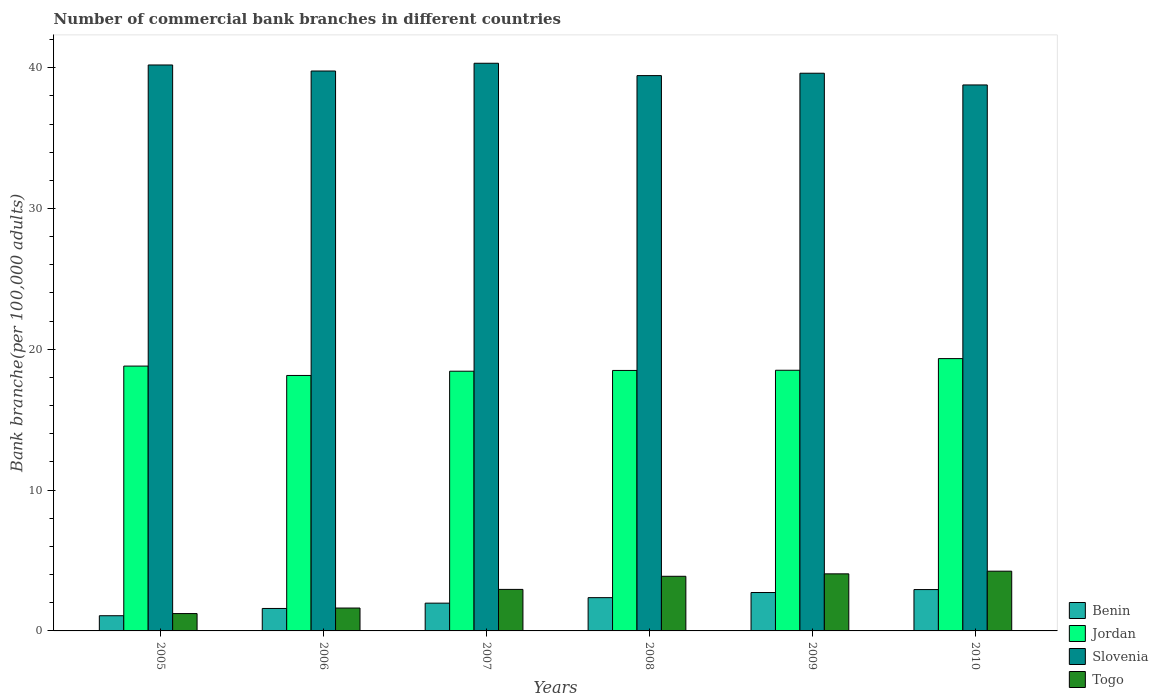How many different coloured bars are there?
Provide a succinct answer. 4. Are the number of bars on each tick of the X-axis equal?
Keep it short and to the point. Yes. What is the number of commercial bank branches in Jordan in 2010?
Provide a short and direct response. 19.34. Across all years, what is the maximum number of commercial bank branches in Benin?
Make the answer very short. 2.94. Across all years, what is the minimum number of commercial bank branches in Jordan?
Offer a very short reply. 18.14. In which year was the number of commercial bank branches in Jordan minimum?
Offer a terse response. 2006. What is the total number of commercial bank branches in Benin in the graph?
Give a very brief answer. 12.67. What is the difference between the number of commercial bank branches in Jordan in 2006 and that in 2007?
Your answer should be compact. -0.3. What is the difference between the number of commercial bank branches in Benin in 2007 and the number of commercial bank branches in Slovenia in 2005?
Your answer should be very brief. -38.22. What is the average number of commercial bank branches in Benin per year?
Offer a very short reply. 2.11. In the year 2007, what is the difference between the number of commercial bank branches in Jordan and number of commercial bank branches in Benin?
Offer a very short reply. 16.47. In how many years, is the number of commercial bank branches in Slovenia greater than 14?
Keep it short and to the point. 6. What is the ratio of the number of commercial bank branches in Jordan in 2008 to that in 2009?
Keep it short and to the point. 1. Is the number of commercial bank branches in Benin in 2007 less than that in 2010?
Provide a succinct answer. Yes. What is the difference between the highest and the second highest number of commercial bank branches in Slovenia?
Offer a terse response. 0.12. What is the difference between the highest and the lowest number of commercial bank branches in Jordan?
Make the answer very short. 1.2. What does the 2nd bar from the left in 2006 represents?
Ensure brevity in your answer.  Jordan. What does the 3rd bar from the right in 2006 represents?
Offer a terse response. Jordan. Is it the case that in every year, the sum of the number of commercial bank branches in Togo and number of commercial bank branches in Slovenia is greater than the number of commercial bank branches in Jordan?
Offer a terse response. Yes. How many bars are there?
Keep it short and to the point. 24. Are all the bars in the graph horizontal?
Your response must be concise. No. How many years are there in the graph?
Ensure brevity in your answer.  6. What is the difference between two consecutive major ticks on the Y-axis?
Your answer should be compact. 10. Are the values on the major ticks of Y-axis written in scientific E-notation?
Offer a very short reply. No. Does the graph contain any zero values?
Offer a terse response. No. Does the graph contain grids?
Provide a short and direct response. No. How many legend labels are there?
Your response must be concise. 4. What is the title of the graph?
Keep it short and to the point. Number of commercial bank branches in different countries. What is the label or title of the Y-axis?
Your answer should be very brief. Bank branche(per 100,0 adults). What is the Bank branche(per 100,000 adults) of Benin in 2005?
Your answer should be very brief. 1.08. What is the Bank branche(per 100,000 adults) in Jordan in 2005?
Give a very brief answer. 18.81. What is the Bank branche(per 100,000 adults) in Slovenia in 2005?
Give a very brief answer. 40.19. What is the Bank branche(per 100,000 adults) in Togo in 2005?
Offer a terse response. 1.23. What is the Bank branche(per 100,000 adults) of Benin in 2006?
Offer a very short reply. 1.59. What is the Bank branche(per 100,000 adults) in Jordan in 2006?
Offer a terse response. 18.14. What is the Bank branche(per 100,000 adults) of Slovenia in 2006?
Ensure brevity in your answer.  39.76. What is the Bank branche(per 100,000 adults) of Togo in 2006?
Provide a succinct answer. 1.63. What is the Bank branche(per 100,000 adults) in Benin in 2007?
Keep it short and to the point. 1.97. What is the Bank branche(per 100,000 adults) of Jordan in 2007?
Give a very brief answer. 18.44. What is the Bank branche(per 100,000 adults) of Slovenia in 2007?
Give a very brief answer. 40.31. What is the Bank branche(per 100,000 adults) in Togo in 2007?
Your answer should be compact. 2.95. What is the Bank branche(per 100,000 adults) of Benin in 2008?
Offer a very short reply. 2.36. What is the Bank branche(per 100,000 adults) of Jordan in 2008?
Provide a short and direct response. 18.5. What is the Bank branche(per 100,000 adults) of Slovenia in 2008?
Give a very brief answer. 39.44. What is the Bank branche(per 100,000 adults) in Togo in 2008?
Ensure brevity in your answer.  3.88. What is the Bank branche(per 100,000 adults) in Benin in 2009?
Give a very brief answer. 2.73. What is the Bank branche(per 100,000 adults) of Jordan in 2009?
Your answer should be very brief. 18.51. What is the Bank branche(per 100,000 adults) in Slovenia in 2009?
Make the answer very short. 39.61. What is the Bank branche(per 100,000 adults) of Togo in 2009?
Give a very brief answer. 4.05. What is the Bank branche(per 100,000 adults) of Benin in 2010?
Give a very brief answer. 2.94. What is the Bank branche(per 100,000 adults) of Jordan in 2010?
Offer a terse response. 19.34. What is the Bank branche(per 100,000 adults) of Slovenia in 2010?
Your response must be concise. 38.77. What is the Bank branche(per 100,000 adults) in Togo in 2010?
Your response must be concise. 4.24. Across all years, what is the maximum Bank branche(per 100,000 adults) in Benin?
Offer a terse response. 2.94. Across all years, what is the maximum Bank branche(per 100,000 adults) of Jordan?
Keep it short and to the point. 19.34. Across all years, what is the maximum Bank branche(per 100,000 adults) in Slovenia?
Provide a succinct answer. 40.31. Across all years, what is the maximum Bank branche(per 100,000 adults) of Togo?
Offer a terse response. 4.24. Across all years, what is the minimum Bank branche(per 100,000 adults) in Benin?
Provide a succinct answer. 1.08. Across all years, what is the minimum Bank branche(per 100,000 adults) of Jordan?
Provide a short and direct response. 18.14. Across all years, what is the minimum Bank branche(per 100,000 adults) of Slovenia?
Keep it short and to the point. 38.77. Across all years, what is the minimum Bank branche(per 100,000 adults) in Togo?
Your response must be concise. 1.23. What is the total Bank branche(per 100,000 adults) in Benin in the graph?
Ensure brevity in your answer.  12.67. What is the total Bank branche(per 100,000 adults) of Jordan in the graph?
Provide a short and direct response. 111.74. What is the total Bank branche(per 100,000 adults) of Slovenia in the graph?
Your answer should be very brief. 238.09. What is the total Bank branche(per 100,000 adults) of Togo in the graph?
Your response must be concise. 17.98. What is the difference between the Bank branche(per 100,000 adults) of Benin in 2005 and that in 2006?
Give a very brief answer. -0.52. What is the difference between the Bank branche(per 100,000 adults) of Jordan in 2005 and that in 2006?
Your answer should be compact. 0.67. What is the difference between the Bank branche(per 100,000 adults) in Slovenia in 2005 and that in 2006?
Make the answer very short. 0.43. What is the difference between the Bank branche(per 100,000 adults) of Togo in 2005 and that in 2006?
Your answer should be very brief. -0.39. What is the difference between the Bank branche(per 100,000 adults) of Benin in 2005 and that in 2007?
Your answer should be very brief. -0.89. What is the difference between the Bank branche(per 100,000 adults) in Jordan in 2005 and that in 2007?
Offer a terse response. 0.36. What is the difference between the Bank branche(per 100,000 adults) of Slovenia in 2005 and that in 2007?
Offer a terse response. -0.12. What is the difference between the Bank branche(per 100,000 adults) in Togo in 2005 and that in 2007?
Make the answer very short. -1.72. What is the difference between the Bank branche(per 100,000 adults) in Benin in 2005 and that in 2008?
Keep it short and to the point. -1.28. What is the difference between the Bank branche(per 100,000 adults) of Jordan in 2005 and that in 2008?
Offer a terse response. 0.31. What is the difference between the Bank branche(per 100,000 adults) in Slovenia in 2005 and that in 2008?
Give a very brief answer. 0.75. What is the difference between the Bank branche(per 100,000 adults) of Togo in 2005 and that in 2008?
Provide a short and direct response. -2.65. What is the difference between the Bank branche(per 100,000 adults) of Benin in 2005 and that in 2009?
Offer a terse response. -1.65. What is the difference between the Bank branche(per 100,000 adults) of Jordan in 2005 and that in 2009?
Make the answer very short. 0.3. What is the difference between the Bank branche(per 100,000 adults) in Slovenia in 2005 and that in 2009?
Offer a terse response. 0.59. What is the difference between the Bank branche(per 100,000 adults) of Togo in 2005 and that in 2009?
Offer a very short reply. -2.82. What is the difference between the Bank branche(per 100,000 adults) in Benin in 2005 and that in 2010?
Ensure brevity in your answer.  -1.86. What is the difference between the Bank branche(per 100,000 adults) in Jordan in 2005 and that in 2010?
Make the answer very short. -0.53. What is the difference between the Bank branche(per 100,000 adults) of Slovenia in 2005 and that in 2010?
Your answer should be very brief. 1.42. What is the difference between the Bank branche(per 100,000 adults) of Togo in 2005 and that in 2010?
Your response must be concise. -3.01. What is the difference between the Bank branche(per 100,000 adults) in Benin in 2006 and that in 2007?
Your response must be concise. -0.38. What is the difference between the Bank branche(per 100,000 adults) of Jordan in 2006 and that in 2007?
Your response must be concise. -0.3. What is the difference between the Bank branche(per 100,000 adults) in Slovenia in 2006 and that in 2007?
Offer a terse response. -0.55. What is the difference between the Bank branche(per 100,000 adults) of Togo in 2006 and that in 2007?
Your answer should be very brief. -1.32. What is the difference between the Bank branche(per 100,000 adults) in Benin in 2006 and that in 2008?
Give a very brief answer. -0.77. What is the difference between the Bank branche(per 100,000 adults) of Jordan in 2006 and that in 2008?
Your answer should be very brief. -0.36. What is the difference between the Bank branche(per 100,000 adults) in Slovenia in 2006 and that in 2008?
Provide a short and direct response. 0.33. What is the difference between the Bank branche(per 100,000 adults) in Togo in 2006 and that in 2008?
Keep it short and to the point. -2.25. What is the difference between the Bank branche(per 100,000 adults) of Benin in 2006 and that in 2009?
Provide a short and direct response. -1.13. What is the difference between the Bank branche(per 100,000 adults) of Jordan in 2006 and that in 2009?
Offer a very short reply. -0.37. What is the difference between the Bank branche(per 100,000 adults) of Slovenia in 2006 and that in 2009?
Give a very brief answer. 0.16. What is the difference between the Bank branche(per 100,000 adults) in Togo in 2006 and that in 2009?
Offer a terse response. -2.43. What is the difference between the Bank branche(per 100,000 adults) of Benin in 2006 and that in 2010?
Give a very brief answer. -1.34. What is the difference between the Bank branche(per 100,000 adults) of Jordan in 2006 and that in 2010?
Your response must be concise. -1.2. What is the difference between the Bank branche(per 100,000 adults) of Slovenia in 2006 and that in 2010?
Offer a terse response. 0.99. What is the difference between the Bank branche(per 100,000 adults) in Togo in 2006 and that in 2010?
Give a very brief answer. -2.62. What is the difference between the Bank branche(per 100,000 adults) of Benin in 2007 and that in 2008?
Keep it short and to the point. -0.39. What is the difference between the Bank branche(per 100,000 adults) of Jordan in 2007 and that in 2008?
Keep it short and to the point. -0.06. What is the difference between the Bank branche(per 100,000 adults) in Slovenia in 2007 and that in 2008?
Make the answer very short. 0.88. What is the difference between the Bank branche(per 100,000 adults) of Togo in 2007 and that in 2008?
Ensure brevity in your answer.  -0.93. What is the difference between the Bank branche(per 100,000 adults) in Benin in 2007 and that in 2009?
Offer a very short reply. -0.76. What is the difference between the Bank branche(per 100,000 adults) of Jordan in 2007 and that in 2009?
Keep it short and to the point. -0.07. What is the difference between the Bank branche(per 100,000 adults) of Slovenia in 2007 and that in 2009?
Your answer should be compact. 0.71. What is the difference between the Bank branche(per 100,000 adults) of Togo in 2007 and that in 2009?
Your response must be concise. -1.1. What is the difference between the Bank branche(per 100,000 adults) in Benin in 2007 and that in 2010?
Your answer should be compact. -0.96. What is the difference between the Bank branche(per 100,000 adults) of Jordan in 2007 and that in 2010?
Offer a terse response. -0.9. What is the difference between the Bank branche(per 100,000 adults) in Slovenia in 2007 and that in 2010?
Your response must be concise. 1.54. What is the difference between the Bank branche(per 100,000 adults) of Togo in 2007 and that in 2010?
Your answer should be very brief. -1.29. What is the difference between the Bank branche(per 100,000 adults) of Benin in 2008 and that in 2009?
Your answer should be very brief. -0.36. What is the difference between the Bank branche(per 100,000 adults) of Jordan in 2008 and that in 2009?
Your response must be concise. -0.01. What is the difference between the Bank branche(per 100,000 adults) of Slovenia in 2008 and that in 2009?
Keep it short and to the point. -0.17. What is the difference between the Bank branche(per 100,000 adults) in Togo in 2008 and that in 2009?
Your response must be concise. -0.17. What is the difference between the Bank branche(per 100,000 adults) in Benin in 2008 and that in 2010?
Offer a terse response. -0.57. What is the difference between the Bank branche(per 100,000 adults) in Jordan in 2008 and that in 2010?
Provide a short and direct response. -0.84. What is the difference between the Bank branche(per 100,000 adults) in Slovenia in 2008 and that in 2010?
Make the answer very short. 0.66. What is the difference between the Bank branche(per 100,000 adults) of Togo in 2008 and that in 2010?
Your answer should be compact. -0.36. What is the difference between the Bank branche(per 100,000 adults) of Benin in 2009 and that in 2010?
Make the answer very short. -0.21. What is the difference between the Bank branche(per 100,000 adults) in Jordan in 2009 and that in 2010?
Provide a short and direct response. -0.83. What is the difference between the Bank branche(per 100,000 adults) of Slovenia in 2009 and that in 2010?
Your answer should be very brief. 0.83. What is the difference between the Bank branche(per 100,000 adults) in Togo in 2009 and that in 2010?
Your answer should be very brief. -0.19. What is the difference between the Bank branche(per 100,000 adults) of Benin in 2005 and the Bank branche(per 100,000 adults) of Jordan in 2006?
Make the answer very short. -17.06. What is the difference between the Bank branche(per 100,000 adults) of Benin in 2005 and the Bank branche(per 100,000 adults) of Slovenia in 2006?
Provide a succinct answer. -38.68. What is the difference between the Bank branche(per 100,000 adults) of Benin in 2005 and the Bank branche(per 100,000 adults) of Togo in 2006?
Provide a short and direct response. -0.55. What is the difference between the Bank branche(per 100,000 adults) in Jordan in 2005 and the Bank branche(per 100,000 adults) in Slovenia in 2006?
Provide a short and direct response. -20.96. What is the difference between the Bank branche(per 100,000 adults) of Jordan in 2005 and the Bank branche(per 100,000 adults) of Togo in 2006?
Provide a short and direct response. 17.18. What is the difference between the Bank branche(per 100,000 adults) of Slovenia in 2005 and the Bank branche(per 100,000 adults) of Togo in 2006?
Make the answer very short. 38.57. What is the difference between the Bank branche(per 100,000 adults) of Benin in 2005 and the Bank branche(per 100,000 adults) of Jordan in 2007?
Your answer should be compact. -17.36. What is the difference between the Bank branche(per 100,000 adults) of Benin in 2005 and the Bank branche(per 100,000 adults) of Slovenia in 2007?
Offer a very short reply. -39.23. What is the difference between the Bank branche(per 100,000 adults) in Benin in 2005 and the Bank branche(per 100,000 adults) in Togo in 2007?
Your response must be concise. -1.87. What is the difference between the Bank branche(per 100,000 adults) of Jordan in 2005 and the Bank branche(per 100,000 adults) of Slovenia in 2007?
Provide a succinct answer. -21.51. What is the difference between the Bank branche(per 100,000 adults) in Jordan in 2005 and the Bank branche(per 100,000 adults) in Togo in 2007?
Your answer should be compact. 15.86. What is the difference between the Bank branche(per 100,000 adults) in Slovenia in 2005 and the Bank branche(per 100,000 adults) in Togo in 2007?
Provide a succinct answer. 37.24. What is the difference between the Bank branche(per 100,000 adults) in Benin in 2005 and the Bank branche(per 100,000 adults) in Jordan in 2008?
Provide a short and direct response. -17.42. What is the difference between the Bank branche(per 100,000 adults) of Benin in 2005 and the Bank branche(per 100,000 adults) of Slovenia in 2008?
Ensure brevity in your answer.  -38.36. What is the difference between the Bank branche(per 100,000 adults) in Benin in 2005 and the Bank branche(per 100,000 adults) in Togo in 2008?
Your response must be concise. -2.8. What is the difference between the Bank branche(per 100,000 adults) in Jordan in 2005 and the Bank branche(per 100,000 adults) in Slovenia in 2008?
Provide a succinct answer. -20.63. What is the difference between the Bank branche(per 100,000 adults) of Jordan in 2005 and the Bank branche(per 100,000 adults) of Togo in 2008?
Make the answer very short. 14.93. What is the difference between the Bank branche(per 100,000 adults) of Slovenia in 2005 and the Bank branche(per 100,000 adults) of Togo in 2008?
Make the answer very short. 36.31. What is the difference between the Bank branche(per 100,000 adults) of Benin in 2005 and the Bank branche(per 100,000 adults) of Jordan in 2009?
Your response must be concise. -17.43. What is the difference between the Bank branche(per 100,000 adults) in Benin in 2005 and the Bank branche(per 100,000 adults) in Slovenia in 2009?
Provide a succinct answer. -38.53. What is the difference between the Bank branche(per 100,000 adults) in Benin in 2005 and the Bank branche(per 100,000 adults) in Togo in 2009?
Offer a very short reply. -2.97. What is the difference between the Bank branche(per 100,000 adults) of Jordan in 2005 and the Bank branche(per 100,000 adults) of Slovenia in 2009?
Offer a terse response. -20.8. What is the difference between the Bank branche(per 100,000 adults) in Jordan in 2005 and the Bank branche(per 100,000 adults) in Togo in 2009?
Keep it short and to the point. 14.75. What is the difference between the Bank branche(per 100,000 adults) of Slovenia in 2005 and the Bank branche(per 100,000 adults) of Togo in 2009?
Your answer should be compact. 36.14. What is the difference between the Bank branche(per 100,000 adults) of Benin in 2005 and the Bank branche(per 100,000 adults) of Jordan in 2010?
Your response must be concise. -18.26. What is the difference between the Bank branche(per 100,000 adults) of Benin in 2005 and the Bank branche(per 100,000 adults) of Slovenia in 2010?
Your response must be concise. -37.69. What is the difference between the Bank branche(per 100,000 adults) in Benin in 2005 and the Bank branche(per 100,000 adults) in Togo in 2010?
Your response must be concise. -3.16. What is the difference between the Bank branche(per 100,000 adults) of Jordan in 2005 and the Bank branche(per 100,000 adults) of Slovenia in 2010?
Offer a very short reply. -19.97. What is the difference between the Bank branche(per 100,000 adults) of Jordan in 2005 and the Bank branche(per 100,000 adults) of Togo in 2010?
Ensure brevity in your answer.  14.57. What is the difference between the Bank branche(per 100,000 adults) of Slovenia in 2005 and the Bank branche(per 100,000 adults) of Togo in 2010?
Your answer should be very brief. 35.95. What is the difference between the Bank branche(per 100,000 adults) in Benin in 2006 and the Bank branche(per 100,000 adults) in Jordan in 2007?
Provide a short and direct response. -16.85. What is the difference between the Bank branche(per 100,000 adults) of Benin in 2006 and the Bank branche(per 100,000 adults) of Slovenia in 2007?
Offer a terse response. -38.72. What is the difference between the Bank branche(per 100,000 adults) of Benin in 2006 and the Bank branche(per 100,000 adults) of Togo in 2007?
Ensure brevity in your answer.  -1.35. What is the difference between the Bank branche(per 100,000 adults) in Jordan in 2006 and the Bank branche(per 100,000 adults) in Slovenia in 2007?
Provide a succinct answer. -22.17. What is the difference between the Bank branche(per 100,000 adults) of Jordan in 2006 and the Bank branche(per 100,000 adults) of Togo in 2007?
Ensure brevity in your answer.  15.19. What is the difference between the Bank branche(per 100,000 adults) of Slovenia in 2006 and the Bank branche(per 100,000 adults) of Togo in 2007?
Make the answer very short. 36.81. What is the difference between the Bank branche(per 100,000 adults) in Benin in 2006 and the Bank branche(per 100,000 adults) in Jordan in 2008?
Your answer should be very brief. -16.9. What is the difference between the Bank branche(per 100,000 adults) of Benin in 2006 and the Bank branche(per 100,000 adults) of Slovenia in 2008?
Provide a short and direct response. -37.84. What is the difference between the Bank branche(per 100,000 adults) of Benin in 2006 and the Bank branche(per 100,000 adults) of Togo in 2008?
Offer a terse response. -2.28. What is the difference between the Bank branche(per 100,000 adults) of Jordan in 2006 and the Bank branche(per 100,000 adults) of Slovenia in 2008?
Give a very brief answer. -21.3. What is the difference between the Bank branche(per 100,000 adults) of Jordan in 2006 and the Bank branche(per 100,000 adults) of Togo in 2008?
Provide a succinct answer. 14.26. What is the difference between the Bank branche(per 100,000 adults) in Slovenia in 2006 and the Bank branche(per 100,000 adults) in Togo in 2008?
Provide a short and direct response. 35.88. What is the difference between the Bank branche(per 100,000 adults) in Benin in 2006 and the Bank branche(per 100,000 adults) in Jordan in 2009?
Your response must be concise. -16.92. What is the difference between the Bank branche(per 100,000 adults) of Benin in 2006 and the Bank branche(per 100,000 adults) of Slovenia in 2009?
Make the answer very short. -38.01. What is the difference between the Bank branche(per 100,000 adults) in Benin in 2006 and the Bank branche(per 100,000 adults) in Togo in 2009?
Your answer should be very brief. -2.46. What is the difference between the Bank branche(per 100,000 adults) in Jordan in 2006 and the Bank branche(per 100,000 adults) in Slovenia in 2009?
Your answer should be very brief. -21.46. What is the difference between the Bank branche(per 100,000 adults) in Jordan in 2006 and the Bank branche(per 100,000 adults) in Togo in 2009?
Ensure brevity in your answer.  14.09. What is the difference between the Bank branche(per 100,000 adults) of Slovenia in 2006 and the Bank branche(per 100,000 adults) of Togo in 2009?
Offer a very short reply. 35.71. What is the difference between the Bank branche(per 100,000 adults) in Benin in 2006 and the Bank branche(per 100,000 adults) in Jordan in 2010?
Offer a terse response. -17.74. What is the difference between the Bank branche(per 100,000 adults) of Benin in 2006 and the Bank branche(per 100,000 adults) of Slovenia in 2010?
Your response must be concise. -37.18. What is the difference between the Bank branche(per 100,000 adults) of Benin in 2006 and the Bank branche(per 100,000 adults) of Togo in 2010?
Your response must be concise. -2.65. What is the difference between the Bank branche(per 100,000 adults) in Jordan in 2006 and the Bank branche(per 100,000 adults) in Slovenia in 2010?
Your response must be concise. -20.63. What is the difference between the Bank branche(per 100,000 adults) of Jordan in 2006 and the Bank branche(per 100,000 adults) of Togo in 2010?
Offer a very short reply. 13.9. What is the difference between the Bank branche(per 100,000 adults) of Slovenia in 2006 and the Bank branche(per 100,000 adults) of Togo in 2010?
Offer a terse response. 35.52. What is the difference between the Bank branche(per 100,000 adults) of Benin in 2007 and the Bank branche(per 100,000 adults) of Jordan in 2008?
Offer a very short reply. -16.53. What is the difference between the Bank branche(per 100,000 adults) in Benin in 2007 and the Bank branche(per 100,000 adults) in Slovenia in 2008?
Your response must be concise. -37.47. What is the difference between the Bank branche(per 100,000 adults) in Benin in 2007 and the Bank branche(per 100,000 adults) in Togo in 2008?
Your answer should be compact. -1.91. What is the difference between the Bank branche(per 100,000 adults) of Jordan in 2007 and the Bank branche(per 100,000 adults) of Slovenia in 2008?
Offer a very short reply. -20.99. What is the difference between the Bank branche(per 100,000 adults) in Jordan in 2007 and the Bank branche(per 100,000 adults) in Togo in 2008?
Your answer should be compact. 14.56. What is the difference between the Bank branche(per 100,000 adults) in Slovenia in 2007 and the Bank branche(per 100,000 adults) in Togo in 2008?
Make the answer very short. 36.43. What is the difference between the Bank branche(per 100,000 adults) of Benin in 2007 and the Bank branche(per 100,000 adults) of Jordan in 2009?
Ensure brevity in your answer.  -16.54. What is the difference between the Bank branche(per 100,000 adults) of Benin in 2007 and the Bank branche(per 100,000 adults) of Slovenia in 2009?
Offer a terse response. -37.63. What is the difference between the Bank branche(per 100,000 adults) of Benin in 2007 and the Bank branche(per 100,000 adults) of Togo in 2009?
Your response must be concise. -2.08. What is the difference between the Bank branche(per 100,000 adults) in Jordan in 2007 and the Bank branche(per 100,000 adults) in Slovenia in 2009?
Offer a terse response. -21.16. What is the difference between the Bank branche(per 100,000 adults) in Jordan in 2007 and the Bank branche(per 100,000 adults) in Togo in 2009?
Your answer should be compact. 14.39. What is the difference between the Bank branche(per 100,000 adults) of Slovenia in 2007 and the Bank branche(per 100,000 adults) of Togo in 2009?
Provide a succinct answer. 36.26. What is the difference between the Bank branche(per 100,000 adults) in Benin in 2007 and the Bank branche(per 100,000 adults) in Jordan in 2010?
Keep it short and to the point. -17.37. What is the difference between the Bank branche(per 100,000 adults) of Benin in 2007 and the Bank branche(per 100,000 adults) of Slovenia in 2010?
Provide a short and direct response. -36.8. What is the difference between the Bank branche(per 100,000 adults) in Benin in 2007 and the Bank branche(per 100,000 adults) in Togo in 2010?
Provide a short and direct response. -2.27. What is the difference between the Bank branche(per 100,000 adults) in Jordan in 2007 and the Bank branche(per 100,000 adults) in Slovenia in 2010?
Offer a very short reply. -20.33. What is the difference between the Bank branche(per 100,000 adults) in Jordan in 2007 and the Bank branche(per 100,000 adults) in Togo in 2010?
Offer a very short reply. 14.2. What is the difference between the Bank branche(per 100,000 adults) of Slovenia in 2007 and the Bank branche(per 100,000 adults) of Togo in 2010?
Your answer should be very brief. 36.07. What is the difference between the Bank branche(per 100,000 adults) in Benin in 2008 and the Bank branche(per 100,000 adults) in Jordan in 2009?
Offer a terse response. -16.15. What is the difference between the Bank branche(per 100,000 adults) of Benin in 2008 and the Bank branche(per 100,000 adults) of Slovenia in 2009?
Offer a terse response. -37.24. What is the difference between the Bank branche(per 100,000 adults) in Benin in 2008 and the Bank branche(per 100,000 adults) in Togo in 2009?
Keep it short and to the point. -1.69. What is the difference between the Bank branche(per 100,000 adults) of Jordan in 2008 and the Bank branche(per 100,000 adults) of Slovenia in 2009?
Your answer should be compact. -21.11. What is the difference between the Bank branche(per 100,000 adults) of Jordan in 2008 and the Bank branche(per 100,000 adults) of Togo in 2009?
Offer a terse response. 14.45. What is the difference between the Bank branche(per 100,000 adults) of Slovenia in 2008 and the Bank branche(per 100,000 adults) of Togo in 2009?
Keep it short and to the point. 35.38. What is the difference between the Bank branche(per 100,000 adults) in Benin in 2008 and the Bank branche(per 100,000 adults) in Jordan in 2010?
Offer a terse response. -16.98. What is the difference between the Bank branche(per 100,000 adults) of Benin in 2008 and the Bank branche(per 100,000 adults) of Slovenia in 2010?
Offer a very short reply. -36.41. What is the difference between the Bank branche(per 100,000 adults) of Benin in 2008 and the Bank branche(per 100,000 adults) of Togo in 2010?
Provide a succinct answer. -1.88. What is the difference between the Bank branche(per 100,000 adults) in Jordan in 2008 and the Bank branche(per 100,000 adults) in Slovenia in 2010?
Make the answer very short. -20.27. What is the difference between the Bank branche(per 100,000 adults) of Jordan in 2008 and the Bank branche(per 100,000 adults) of Togo in 2010?
Your answer should be compact. 14.26. What is the difference between the Bank branche(per 100,000 adults) in Slovenia in 2008 and the Bank branche(per 100,000 adults) in Togo in 2010?
Make the answer very short. 35.19. What is the difference between the Bank branche(per 100,000 adults) of Benin in 2009 and the Bank branche(per 100,000 adults) of Jordan in 2010?
Your response must be concise. -16.61. What is the difference between the Bank branche(per 100,000 adults) in Benin in 2009 and the Bank branche(per 100,000 adults) in Slovenia in 2010?
Your answer should be very brief. -36.05. What is the difference between the Bank branche(per 100,000 adults) in Benin in 2009 and the Bank branche(per 100,000 adults) in Togo in 2010?
Provide a short and direct response. -1.52. What is the difference between the Bank branche(per 100,000 adults) in Jordan in 2009 and the Bank branche(per 100,000 adults) in Slovenia in 2010?
Provide a short and direct response. -20.26. What is the difference between the Bank branche(per 100,000 adults) in Jordan in 2009 and the Bank branche(per 100,000 adults) in Togo in 2010?
Your answer should be compact. 14.27. What is the difference between the Bank branche(per 100,000 adults) of Slovenia in 2009 and the Bank branche(per 100,000 adults) of Togo in 2010?
Offer a terse response. 35.36. What is the average Bank branche(per 100,000 adults) in Benin per year?
Make the answer very short. 2.11. What is the average Bank branche(per 100,000 adults) in Jordan per year?
Your response must be concise. 18.62. What is the average Bank branche(per 100,000 adults) of Slovenia per year?
Offer a very short reply. 39.68. What is the average Bank branche(per 100,000 adults) in Togo per year?
Make the answer very short. 3. In the year 2005, what is the difference between the Bank branche(per 100,000 adults) in Benin and Bank branche(per 100,000 adults) in Jordan?
Give a very brief answer. -17.73. In the year 2005, what is the difference between the Bank branche(per 100,000 adults) in Benin and Bank branche(per 100,000 adults) in Slovenia?
Provide a short and direct response. -39.11. In the year 2005, what is the difference between the Bank branche(per 100,000 adults) of Benin and Bank branche(per 100,000 adults) of Togo?
Make the answer very short. -0.15. In the year 2005, what is the difference between the Bank branche(per 100,000 adults) in Jordan and Bank branche(per 100,000 adults) in Slovenia?
Your answer should be compact. -21.38. In the year 2005, what is the difference between the Bank branche(per 100,000 adults) in Jordan and Bank branche(per 100,000 adults) in Togo?
Offer a very short reply. 17.58. In the year 2005, what is the difference between the Bank branche(per 100,000 adults) in Slovenia and Bank branche(per 100,000 adults) in Togo?
Give a very brief answer. 38.96. In the year 2006, what is the difference between the Bank branche(per 100,000 adults) in Benin and Bank branche(per 100,000 adults) in Jordan?
Offer a terse response. -16.55. In the year 2006, what is the difference between the Bank branche(per 100,000 adults) of Benin and Bank branche(per 100,000 adults) of Slovenia?
Ensure brevity in your answer.  -38.17. In the year 2006, what is the difference between the Bank branche(per 100,000 adults) in Benin and Bank branche(per 100,000 adults) in Togo?
Offer a very short reply. -0.03. In the year 2006, what is the difference between the Bank branche(per 100,000 adults) of Jordan and Bank branche(per 100,000 adults) of Slovenia?
Provide a succinct answer. -21.62. In the year 2006, what is the difference between the Bank branche(per 100,000 adults) of Jordan and Bank branche(per 100,000 adults) of Togo?
Offer a very short reply. 16.52. In the year 2006, what is the difference between the Bank branche(per 100,000 adults) of Slovenia and Bank branche(per 100,000 adults) of Togo?
Provide a succinct answer. 38.14. In the year 2007, what is the difference between the Bank branche(per 100,000 adults) in Benin and Bank branche(per 100,000 adults) in Jordan?
Provide a succinct answer. -16.47. In the year 2007, what is the difference between the Bank branche(per 100,000 adults) of Benin and Bank branche(per 100,000 adults) of Slovenia?
Give a very brief answer. -38.34. In the year 2007, what is the difference between the Bank branche(per 100,000 adults) of Benin and Bank branche(per 100,000 adults) of Togo?
Make the answer very short. -0.98. In the year 2007, what is the difference between the Bank branche(per 100,000 adults) of Jordan and Bank branche(per 100,000 adults) of Slovenia?
Offer a very short reply. -21.87. In the year 2007, what is the difference between the Bank branche(per 100,000 adults) in Jordan and Bank branche(per 100,000 adults) in Togo?
Your answer should be very brief. 15.49. In the year 2007, what is the difference between the Bank branche(per 100,000 adults) in Slovenia and Bank branche(per 100,000 adults) in Togo?
Your response must be concise. 37.36. In the year 2008, what is the difference between the Bank branche(per 100,000 adults) of Benin and Bank branche(per 100,000 adults) of Jordan?
Your response must be concise. -16.14. In the year 2008, what is the difference between the Bank branche(per 100,000 adults) in Benin and Bank branche(per 100,000 adults) in Slovenia?
Ensure brevity in your answer.  -37.07. In the year 2008, what is the difference between the Bank branche(per 100,000 adults) in Benin and Bank branche(per 100,000 adults) in Togo?
Your response must be concise. -1.52. In the year 2008, what is the difference between the Bank branche(per 100,000 adults) of Jordan and Bank branche(per 100,000 adults) of Slovenia?
Offer a terse response. -20.94. In the year 2008, what is the difference between the Bank branche(per 100,000 adults) in Jordan and Bank branche(per 100,000 adults) in Togo?
Keep it short and to the point. 14.62. In the year 2008, what is the difference between the Bank branche(per 100,000 adults) of Slovenia and Bank branche(per 100,000 adults) of Togo?
Provide a short and direct response. 35.56. In the year 2009, what is the difference between the Bank branche(per 100,000 adults) of Benin and Bank branche(per 100,000 adults) of Jordan?
Your response must be concise. -15.78. In the year 2009, what is the difference between the Bank branche(per 100,000 adults) of Benin and Bank branche(per 100,000 adults) of Slovenia?
Give a very brief answer. -36.88. In the year 2009, what is the difference between the Bank branche(per 100,000 adults) of Benin and Bank branche(per 100,000 adults) of Togo?
Keep it short and to the point. -1.33. In the year 2009, what is the difference between the Bank branche(per 100,000 adults) of Jordan and Bank branche(per 100,000 adults) of Slovenia?
Ensure brevity in your answer.  -21.09. In the year 2009, what is the difference between the Bank branche(per 100,000 adults) of Jordan and Bank branche(per 100,000 adults) of Togo?
Offer a very short reply. 14.46. In the year 2009, what is the difference between the Bank branche(per 100,000 adults) in Slovenia and Bank branche(per 100,000 adults) in Togo?
Provide a succinct answer. 35.55. In the year 2010, what is the difference between the Bank branche(per 100,000 adults) in Benin and Bank branche(per 100,000 adults) in Jordan?
Your answer should be compact. -16.4. In the year 2010, what is the difference between the Bank branche(per 100,000 adults) of Benin and Bank branche(per 100,000 adults) of Slovenia?
Offer a very short reply. -35.84. In the year 2010, what is the difference between the Bank branche(per 100,000 adults) of Benin and Bank branche(per 100,000 adults) of Togo?
Make the answer very short. -1.31. In the year 2010, what is the difference between the Bank branche(per 100,000 adults) of Jordan and Bank branche(per 100,000 adults) of Slovenia?
Your answer should be very brief. -19.43. In the year 2010, what is the difference between the Bank branche(per 100,000 adults) in Jordan and Bank branche(per 100,000 adults) in Togo?
Your answer should be compact. 15.1. In the year 2010, what is the difference between the Bank branche(per 100,000 adults) in Slovenia and Bank branche(per 100,000 adults) in Togo?
Offer a very short reply. 34.53. What is the ratio of the Bank branche(per 100,000 adults) of Benin in 2005 to that in 2006?
Keep it short and to the point. 0.68. What is the ratio of the Bank branche(per 100,000 adults) in Jordan in 2005 to that in 2006?
Offer a very short reply. 1.04. What is the ratio of the Bank branche(per 100,000 adults) in Slovenia in 2005 to that in 2006?
Offer a terse response. 1.01. What is the ratio of the Bank branche(per 100,000 adults) of Togo in 2005 to that in 2006?
Provide a short and direct response. 0.76. What is the ratio of the Bank branche(per 100,000 adults) of Benin in 2005 to that in 2007?
Offer a terse response. 0.55. What is the ratio of the Bank branche(per 100,000 adults) of Jordan in 2005 to that in 2007?
Give a very brief answer. 1.02. What is the ratio of the Bank branche(per 100,000 adults) of Togo in 2005 to that in 2007?
Your answer should be compact. 0.42. What is the ratio of the Bank branche(per 100,000 adults) of Benin in 2005 to that in 2008?
Your answer should be very brief. 0.46. What is the ratio of the Bank branche(per 100,000 adults) of Jordan in 2005 to that in 2008?
Offer a very short reply. 1.02. What is the ratio of the Bank branche(per 100,000 adults) in Slovenia in 2005 to that in 2008?
Keep it short and to the point. 1.02. What is the ratio of the Bank branche(per 100,000 adults) of Togo in 2005 to that in 2008?
Your response must be concise. 0.32. What is the ratio of the Bank branche(per 100,000 adults) in Benin in 2005 to that in 2009?
Ensure brevity in your answer.  0.4. What is the ratio of the Bank branche(per 100,000 adults) in Slovenia in 2005 to that in 2009?
Make the answer very short. 1.01. What is the ratio of the Bank branche(per 100,000 adults) in Togo in 2005 to that in 2009?
Provide a short and direct response. 0.3. What is the ratio of the Bank branche(per 100,000 adults) of Benin in 2005 to that in 2010?
Give a very brief answer. 0.37. What is the ratio of the Bank branche(per 100,000 adults) of Jordan in 2005 to that in 2010?
Provide a succinct answer. 0.97. What is the ratio of the Bank branche(per 100,000 adults) in Slovenia in 2005 to that in 2010?
Your answer should be very brief. 1.04. What is the ratio of the Bank branche(per 100,000 adults) of Togo in 2005 to that in 2010?
Your answer should be very brief. 0.29. What is the ratio of the Bank branche(per 100,000 adults) in Benin in 2006 to that in 2007?
Your response must be concise. 0.81. What is the ratio of the Bank branche(per 100,000 adults) of Jordan in 2006 to that in 2007?
Give a very brief answer. 0.98. What is the ratio of the Bank branche(per 100,000 adults) in Slovenia in 2006 to that in 2007?
Ensure brevity in your answer.  0.99. What is the ratio of the Bank branche(per 100,000 adults) in Togo in 2006 to that in 2007?
Give a very brief answer. 0.55. What is the ratio of the Bank branche(per 100,000 adults) of Benin in 2006 to that in 2008?
Offer a terse response. 0.68. What is the ratio of the Bank branche(per 100,000 adults) of Jordan in 2006 to that in 2008?
Ensure brevity in your answer.  0.98. What is the ratio of the Bank branche(per 100,000 adults) of Slovenia in 2006 to that in 2008?
Ensure brevity in your answer.  1.01. What is the ratio of the Bank branche(per 100,000 adults) in Togo in 2006 to that in 2008?
Make the answer very short. 0.42. What is the ratio of the Bank branche(per 100,000 adults) in Benin in 2006 to that in 2009?
Give a very brief answer. 0.58. What is the ratio of the Bank branche(per 100,000 adults) in Jordan in 2006 to that in 2009?
Your answer should be compact. 0.98. What is the ratio of the Bank branche(per 100,000 adults) of Slovenia in 2006 to that in 2009?
Your answer should be compact. 1. What is the ratio of the Bank branche(per 100,000 adults) in Togo in 2006 to that in 2009?
Offer a terse response. 0.4. What is the ratio of the Bank branche(per 100,000 adults) of Benin in 2006 to that in 2010?
Provide a short and direct response. 0.54. What is the ratio of the Bank branche(per 100,000 adults) of Jordan in 2006 to that in 2010?
Make the answer very short. 0.94. What is the ratio of the Bank branche(per 100,000 adults) of Slovenia in 2006 to that in 2010?
Provide a succinct answer. 1.03. What is the ratio of the Bank branche(per 100,000 adults) in Togo in 2006 to that in 2010?
Your answer should be compact. 0.38. What is the ratio of the Bank branche(per 100,000 adults) in Benin in 2007 to that in 2008?
Your response must be concise. 0.83. What is the ratio of the Bank branche(per 100,000 adults) of Slovenia in 2007 to that in 2008?
Give a very brief answer. 1.02. What is the ratio of the Bank branche(per 100,000 adults) of Togo in 2007 to that in 2008?
Give a very brief answer. 0.76. What is the ratio of the Bank branche(per 100,000 adults) in Benin in 2007 to that in 2009?
Ensure brevity in your answer.  0.72. What is the ratio of the Bank branche(per 100,000 adults) in Jordan in 2007 to that in 2009?
Give a very brief answer. 1. What is the ratio of the Bank branche(per 100,000 adults) in Slovenia in 2007 to that in 2009?
Keep it short and to the point. 1.02. What is the ratio of the Bank branche(per 100,000 adults) of Togo in 2007 to that in 2009?
Your response must be concise. 0.73. What is the ratio of the Bank branche(per 100,000 adults) of Benin in 2007 to that in 2010?
Provide a short and direct response. 0.67. What is the ratio of the Bank branche(per 100,000 adults) of Jordan in 2007 to that in 2010?
Keep it short and to the point. 0.95. What is the ratio of the Bank branche(per 100,000 adults) in Slovenia in 2007 to that in 2010?
Your answer should be compact. 1.04. What is the ratio of the Bank branche(per 100,000 adults) in Togo in 2007 to that in 2010?
Provide a succinct answer. 0.7. What is the ratio of the Bank branche(per 100,000 adults) in Benin in 2008 to that in 2009?
Your answer should be very brief. 0.87. What is the ratio of the Bank branche(per 100,000 adults) of Slovenia in 2008 to that in 2009?
Make the answer very short. 1. What is the ratio of the Bank branche(per 100,000 adults) of Togo in 2008 to that in 2009?
Provide a short and direct response. 0.96. What is the ratio of the Bank branche(per 100,000 adults) in Benin in 2008 to that in 2010?
Offer a terse response. 0.8. What is the ratio of the Bank branche(per 100,000 adults) in Jordan in 2008 to that in 2010?
Provide a succinct answer. 0.96. What is the ratio of the Bank branche(per 100,000 adults) in Slovenia in 2008 to that in 2010?
Offer a very short reply. 1.02. What is the ratio of the Bank branche(per 100,000 adults) of Togo in 2008 to that in 2010?
Ensure brevity in your answer.  0.91. What is the ratio of the Bank branche(per 100,000 adults) of Jordan in 2009 to that in 2010?
Make the answer very short. 0.96. What is the ratio of the Bank branche(per 100,000 adults) of Slovenia in 2009 to that in 2010?
Offer a very short reply. 1.02. What is the ratio of the Bank branche(per 100,000 adults) of Togo in 2009 to that in 2010?
Provide a short and direct response. 0.96. What is the difference between the highest and the second highest Bank branche(per 100,000 adults) of Benin?
Give a very brief answer. 0.21. What is the difference between the highest and the second highest Bank branche(per 100,000 adults) in Jordan?
Give a very brief answer. 0.53. What is the difference between the highest and the second highest Bank branche(per 100,000 adults) in Slovenia?
Provide a succinct answer. 0.12. What is the difference between the highest and the second highest Bank branche(per 100,000 adults) of Togo?
Your response must be concise. 0.19. What is the difference between the highest and the lowest Bank branche(per 100,000 adults) of Benin?
Your answer should be very brief. 1.86. What is the difference between the highest and the lowest Bank branche(per 100,000 adults) in Jordan?
Give a very brief answer. 1.2. What is the difference between the highest and the lowest Bank branche(per 100,000 adults) of Slovenia?
Your answer should be compact. 1.54. What is the difference between the highest and the lowest Bank branche(per 100,000 adults) of Togo?
Your response must be concise. 3.01. 